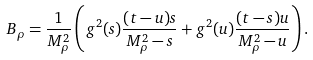Convert formula to latex. <formula><loc_0><loc_0><loc_500><loc_500>B _ { \rho } = \frac { 1 } { M ^ { 2 } _ { \rho } } \left ( g ^ { 2 } ( s ) \frac { ( t - u ) s } { M ^ { 2 } _ { \rho } - s } + g ^ { 2 } ( u ) \frac { ( t - s ) u } { M ^ { 2 } _ { \rho } - u } \right ) .</formula> 